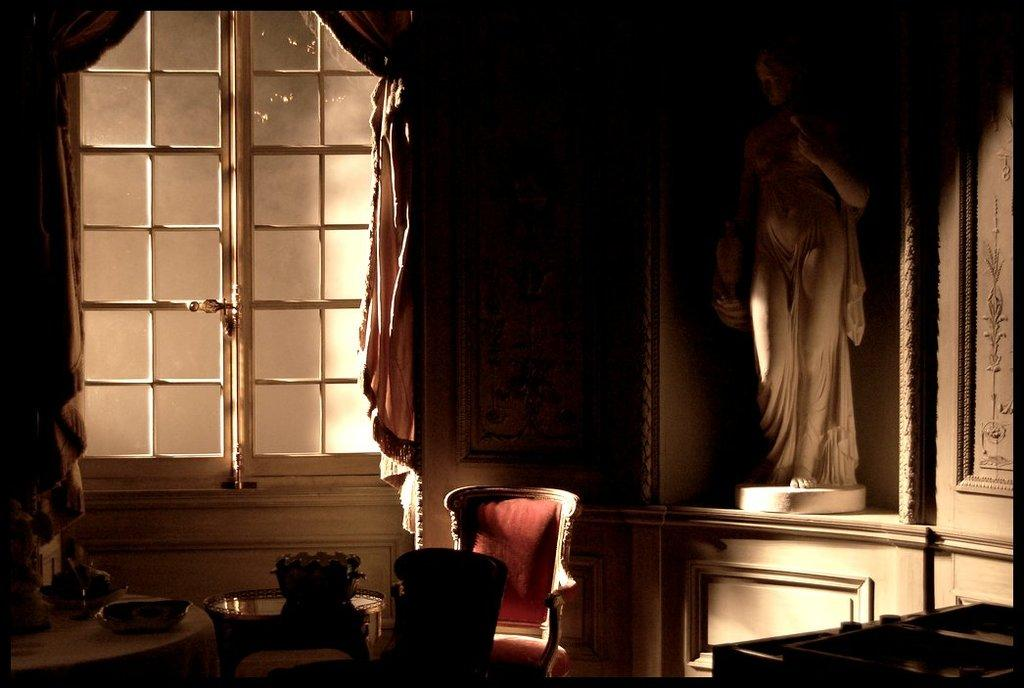What type of furniture is present in the image? There are chairs and tables in the image. What objects are used for holding or serving food in the image? There are bowls in the image. What type of decorative item can be seen in the image? There is a statue in the image. What architectural feature is present in the image? There is a window in the image. What type of window treatment is present in the image? There are curtains in the image. Can you describe any other objects present in the image? There are some unspecified objects in the image. How many children are playing with the fifth object in the image? There is no mention of a fifth object or children in the image. 